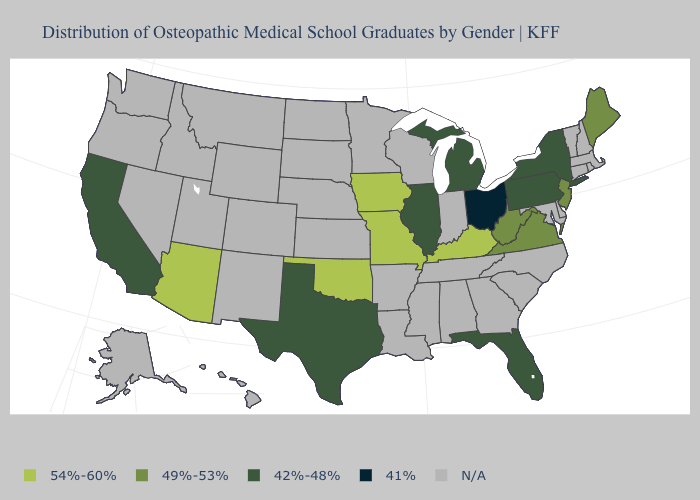Name the states that have a value in the range 42%-48%?
Concise answer only. California, Florida, Illinois, Michigan, New York, Pennsylvania, Texas. Does Ohio have the lowest value in the USA?
Write a very short answer. Yes. Which states have the highest value in the USA?
Be succinct. Arizona, Iowa, Kentucky, Missouri, Oklahoma. Which states have the lowest value in the West?
Answer briefly. California. Is the legend a continuous bar?
Keep it brief. No. What is the highest value in the South ?
Answer briefly. 54%-60%. Does the map have missing data?
Short answer required. Yes. Name the states that have a value in the range N/A?
Answer briefly. Alabama, Alaska, Arkansas, Colorado, Connecticut, Delaware, Georgia, Hawaii, Idaho, Indiana, Kansas, Louisiana, Maryland, Massachusetts, Minnesota, Mississippi, Montana, Nebraska, Nevada, New Hampshire, New Mexico, North Carolina, North Dakota, Oregon, Rhode Island, South Carolina, South Dakota, Tennessee, Utah, Vermont, Washington, Wisconsin, Wyoming. Which states have the lowest value in the MidWest?
Write a very short answer. Ohio. Does Iowa have the lowest value in the USA?
Keep it brief. No. Name the states that have a value in the range 54%-60%?
Give a very brief answer. Arizona, Iowa, Kentucky, Missouri, Oklahoma. What is the lowest value in the South?
Answer briefly. 42%-48%. Does the map have missing data?
Give a very brief answer. Yes. What is the value of Kentucky?
Concise answer only. 54%-60%. 